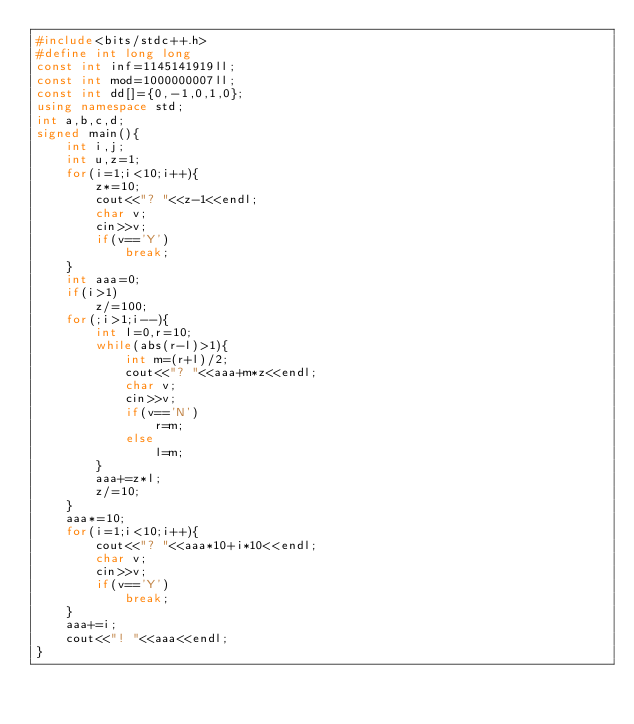Convert code to text. <code><loc_0><loc_0><loc_500><loc_500><_C++_>#include<bits/stdc++.h>
#define int long long
const int inf=1145141919ll;
const int mod=1000000007ll;
const int dd[]={0,-1,0,1,0};
using namespace std;
int a,b,c,d;
signed main(){
	int i,j;
	int u,z=1;
	for(i=1;i<10;i++){
		z*=10;
		cout<<"? "<<z-1<<endl;
		char v;
		cin>>v;
		if(v=='Y')
			break;
	}
	int aaa=0;
	if(i>1)
		z/=100;
	for(;i>1;i--){
		int l=0,r=10;
		while(abs(r-l)>1){
			int m=(r+l)/2;
			cout<<"? "<<aaa+m*z<<endl;
			char v;
			cin>>v;
			if(v=='N')
				r=m;
			else
				l=m;
		}
		aaa+=z*l;
		z/=10;
	}
	aaa*=10;
	for(i=1;i<10;i++){
		cout<<"? "<<aaa*10+i*10<<endl;
		char v;
		cin>>v;
		if(v=='Y')
			break;
	}
	aaa+=i;
	cout<<"! "<<aaa<<endl;
}</code> 